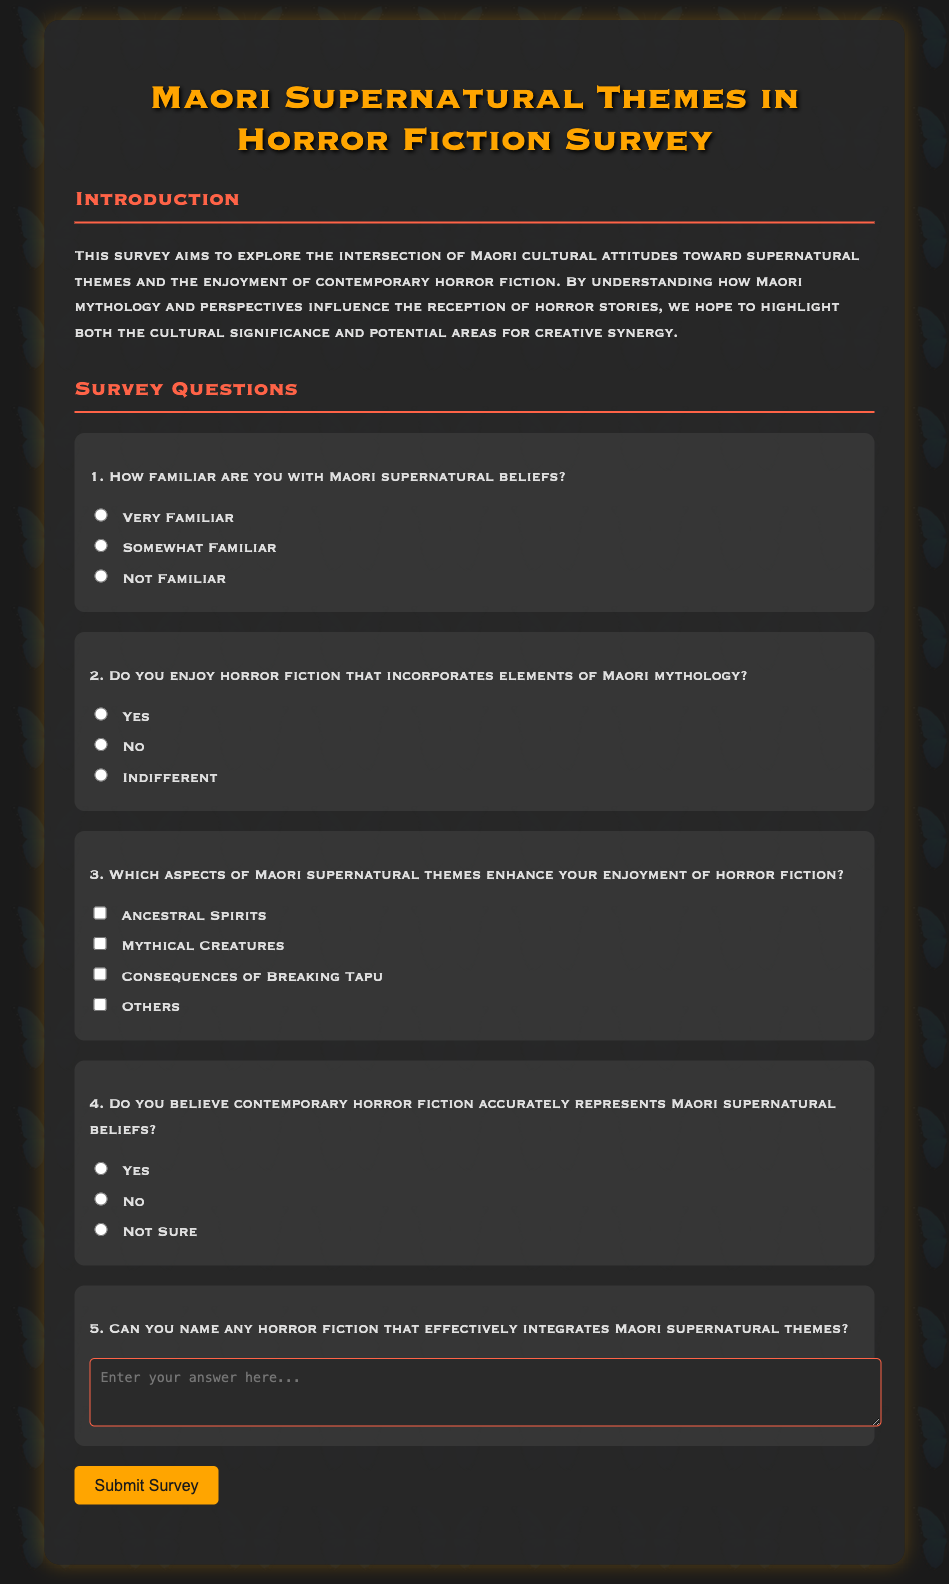What is the title of the survey? The title is presented at the top of the document.
Answer: Maori Supernatural Themes in Horror Fiction Survey How many options are available for question 1? The options are listed under the first question regarding familiarity with Maori supernatural beliefs.
Answer: Three What is the color of the submit button? The color of the submit button is specified in the styling section of the document.
Answer: Orange What are the themes mentioned in question 3? The themes are listed as checkbox options under question 3 regarding Maori supernatural themes.
Answer: Ancestral Spirits, Mythical Creatures, Consequences of Breaking Tapu, Others Is there a question about the accuracy of contemporary horror fiction? The fourth question explicitly asks about the accuracy of contemporary horror fiction in representing Maori beliefs.
Answer: Yes What is the purpose of the survey as stated in the document? The purpose is described in the introduction section of the document.
Answer: To explore the intersection of Maori cultural attitudes and horror fiction enjoyment Which section contains the introductory information? The introductory information is found under a specific heading in the document.
Answer: The Introduction section What kind of responses does question 5 require? This question involves identifying specific works of horror fiction.
Answer: Short Answer 